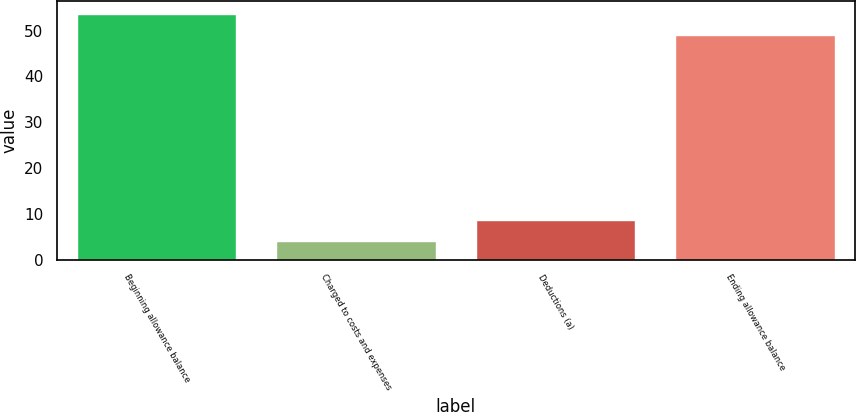Convert chart. <chart><loc_0><loc_0><loc_500><loc_500><bar_chart><fcel>Beginning allowance balance<fcel>Charged to costs and expenses<fcel>Deductions (a)<fcel>Ending allowance balance<nl><fcel>53.7<fcel>4<fcel>8.7<fcel>49<nl></chart> 